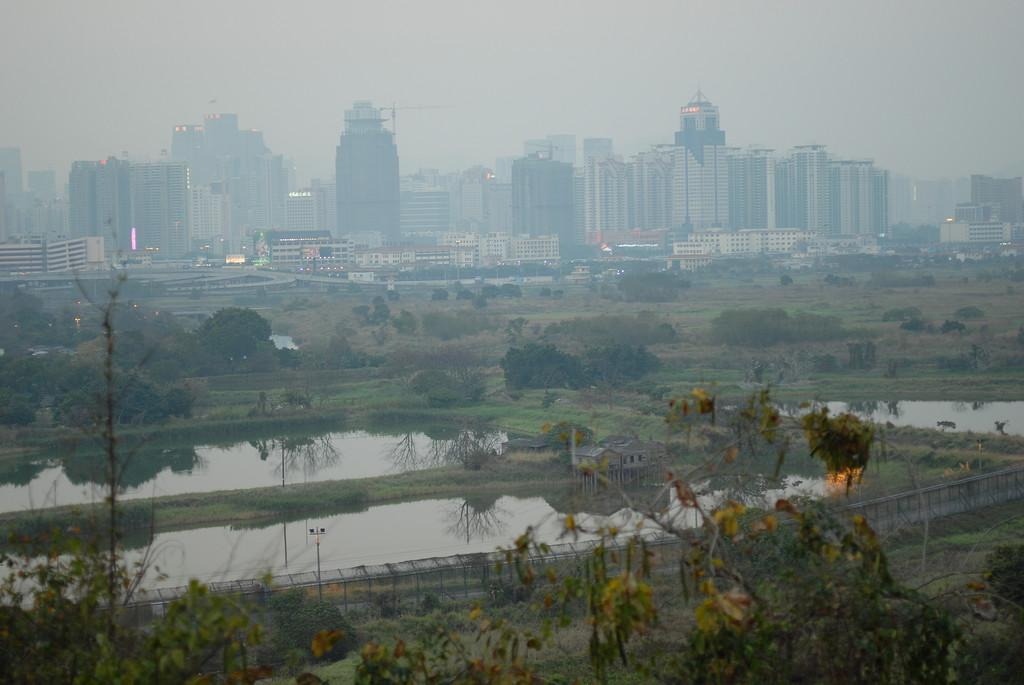What type of water features can be seen in the image? There are ponds in the image. What is placed across the ponds? There is fencing across the ponds. What can be seen in the background of the image? There are trees and buildings in the background of the image. How much sugar is dissolved in the ponds in the image? There is no information about sugar in the image, as it only features ponds with fencing and a background with trees and buildings. 